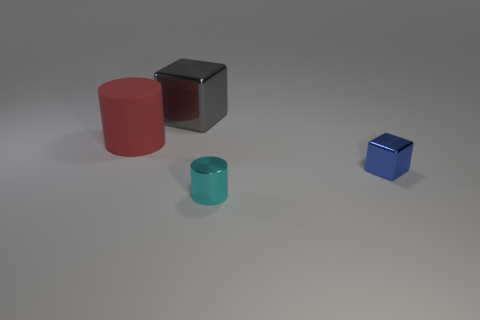Are there any other things of the same color as the metallic cylinder? Upon closer inspection of the image, it seems that there are no other objects sharing the exact hue of the metallic cylinder. However, the red cylinder seems to have a similar but not the same saturation level to the metallic cylinder. 